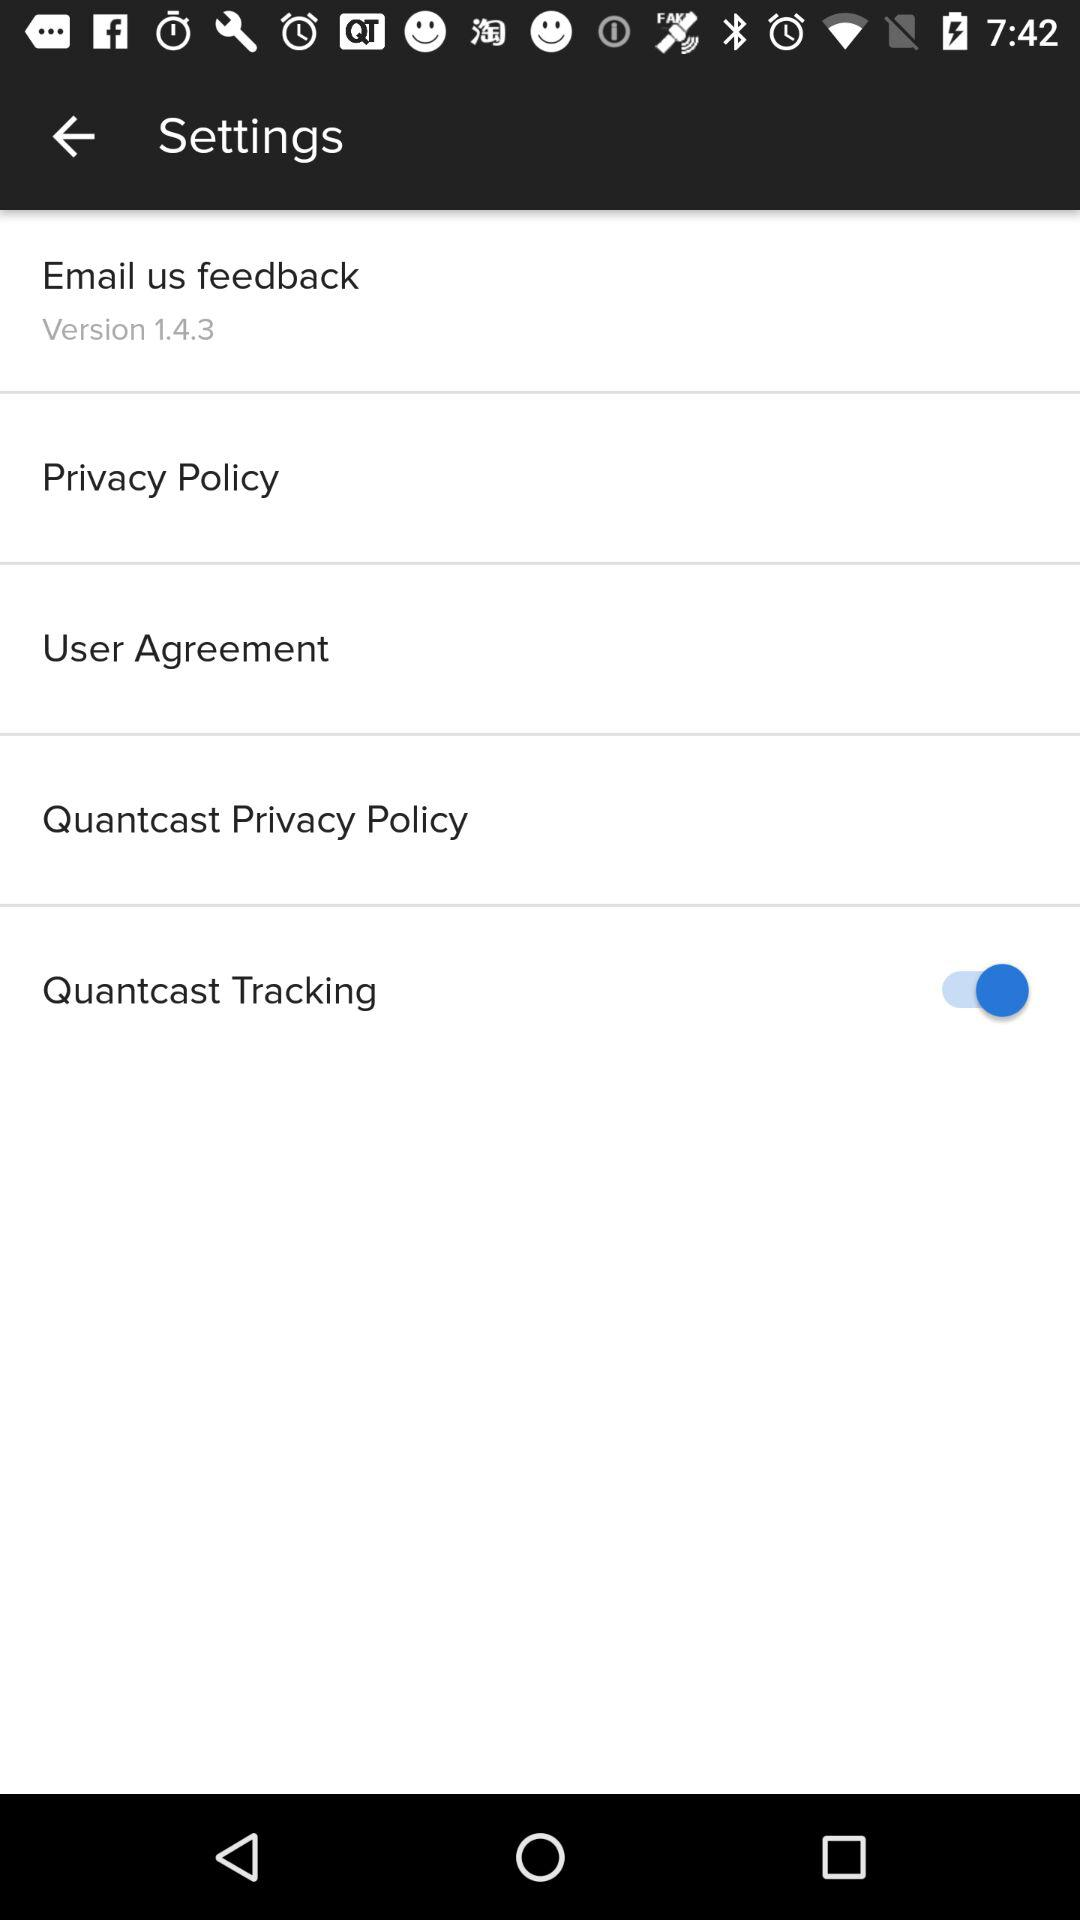Has the user agreed to the privacy policy?
When the provided information is insufficient, respond with <no answer>. <no answer> 